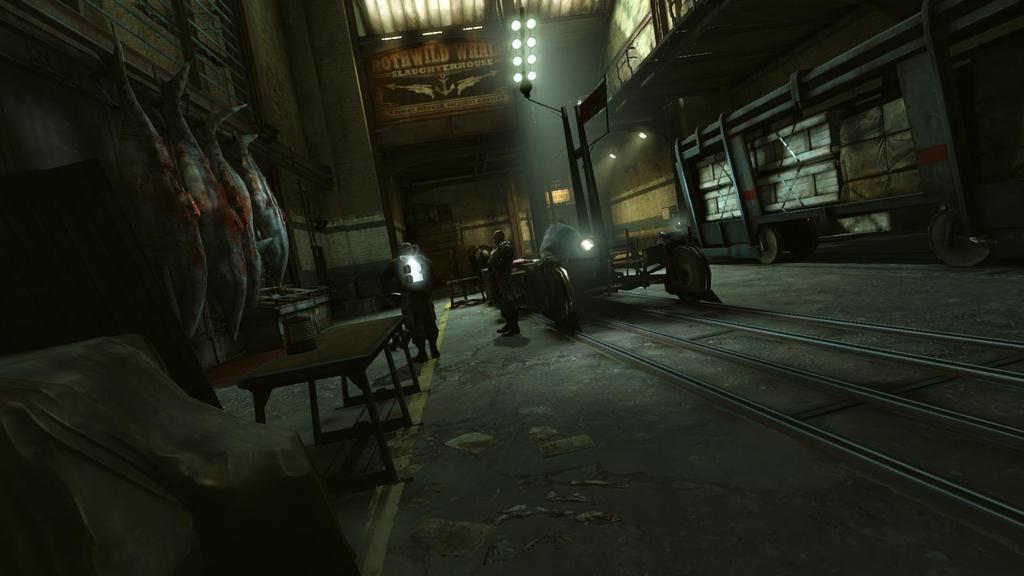In one or two sentences, can you explain what this image depicts? In this picture we can see an inside view of a building, here we can see few people on the ground and we can see a table, meat, wall, lights and some objects. 